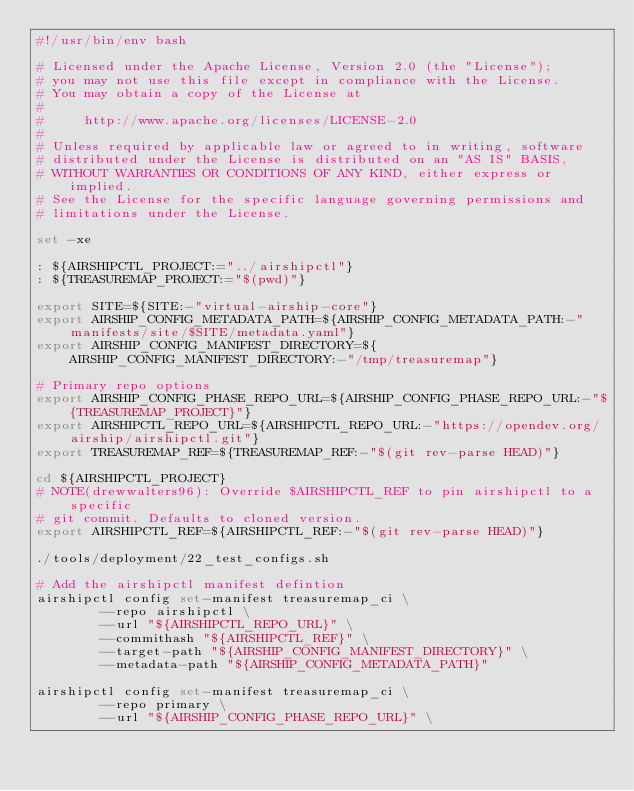Convert code to text. <code><loc_0><loc_0><loc_500><loc_500><_Bash_>#!/usr/bin/env bash

# Licensed under the Apache License, Version 2.0 (the "License");
# you may not use this file except in compliance with the License.
# You may obtain a copy of the License at
#
#     http://www.apache.org/licenses/LICENSE-2.0
#
# Unless required by applicable law or agreed to in writing, software
# distributed under the License is distributed on an "AS IS" BASIS,
# WITHOUT WARRANTIES OR CONDITIONS OF ANY KIND, either express or implied.
# See the License for the specific language governing permissions and
# limitations under the License.

set -xe

: ${AIRSHIPCTL_PROJECT:="../airshipctl"}
: ${TREASUREMAP_PROJECT:="$(pwd)"}

export SITE=${SITE:-"virtual-airship-core"}
export AIRSHIP_CONFIG_METADATA_PATH=${AIRSHIP_CONFIG_METADATA_PATH:-"manifests/site/$SITE/metadata.yaml"}
export AIRSHIP_CONFIG_MANIFEST_DIRECTORY=${AIRSHIP_CONFIG_MANIFEST_DIRECTORY:-"/tmp/treasuremap"}

# Primary repo options
export AIRSHIP_CONFIG_PHASE_REPO_URL=${AIRSHIP_CONFIG_PHASE_REPO_URL:-"${TREASUREMAP_PROJECT}"}
export AIRSHIPCTL_REPO_URL=${AIRSHIPCTL_REPO_URL:-"https://opendev.org/airship/airshipctl.git"}
export TREASUREMAP_REF=${TREASUREMAP_REF:-"$(git rev-parse HEAD)"}

cd ${AIRSHIPCTL_PROJECT}
# NOTE(drewwalters96): Override $AIRSHIPCTL_REF to pin airshipctl to a specific
# git commit. Defaults to cloned version.
export AIRSHIPCTL_REF=${AIRSHIPCTL_REF:-"$(git rev-parse HEAD)"}

./tools/deployment/22_test_configs.sh

# Add the airshipctl manifest defintion
airshipctl config set-manifest treasuremap_ci \
        --repo airshipctl \
        --url "${AIRSHIPCTL_REPO_URL}" \
        --commithash "${AIRSHIPCTL_REF}" \
        --target-path "${AIRSHIP_CONFIG_MANIFEST_DIRECTORY}" \
        --metadata-path "${AIRSHIP_CONFIG_METADATA_PATH}"

airshipctl config set-manifest treasuremap_ci \
        --repo primary \
        --url "${AIRSHIP_CONFIG_PHASE_REPO_URL}" \</code> 